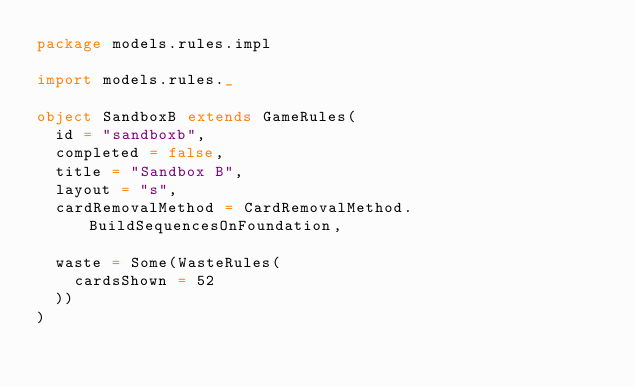Convert code to text. <code><loc_0><loc_0><loc_500><loc_500><_Scala_>package models.rules.impl

import models.rules._

object SandboxB extends GameRules(
  id = "sandboxb",
  completed = false,
  title = "Sandbox B",
  layout = "s",
  cardRemovalMethod = CardRemovalMethod.BuildSequencesOnFoundation,

  waste = Some(WasteRules(
    cardsShown = 52
  ))
)
</code> 